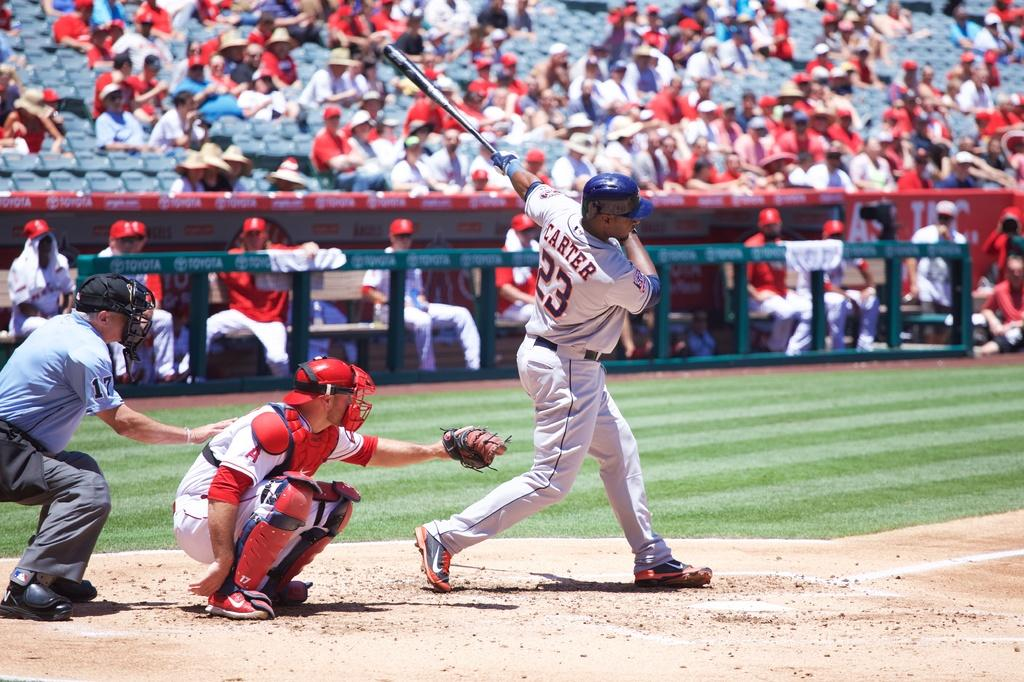<image>
Relay a brief, clear account of the picture shown. A baseball player named Carter has just swung the bat 